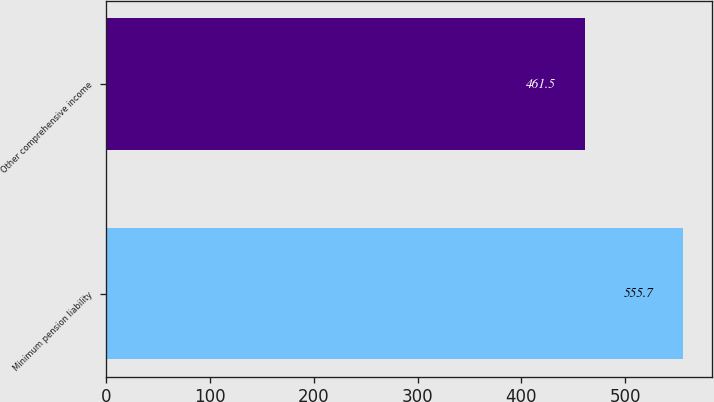Convert chart. <chart><loc_0><loc_0><loc_500><loc_500><bar_chart><fcel>Minimum pension liability<fcel>Other comprehensive income<nl><fcel>555.7<fcel>461.5<nl></chart> 